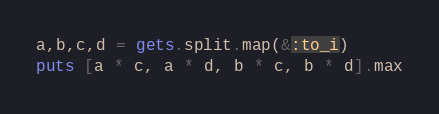Convert code to text. <code><loc_0><loc_0><loc_500><loc_500><_Ruby_>a,b,c,d = gets.split.map(&:to_i)
puts [a * c, a * d, b * c, b * d].max
</code> 